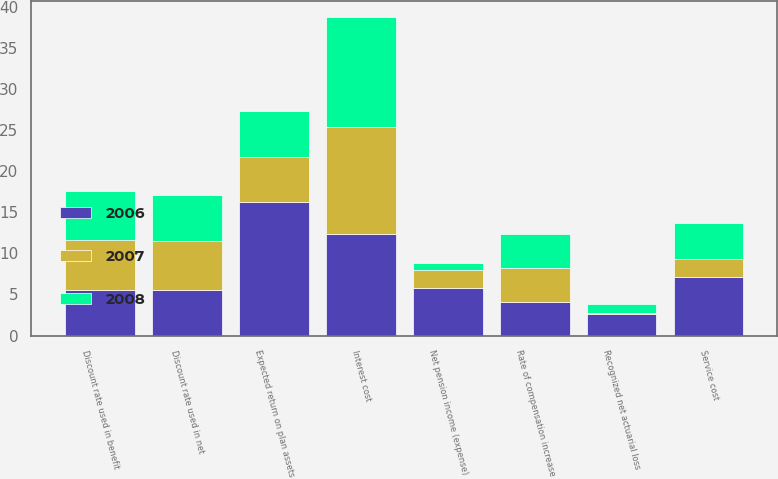<chart> <loc_0><loc_0><loc_500><loc_500><stacked_bar_chart><ecel><fcel>Service cost<fcel>Interest cost<fcel>Expected return on plan assets<fcel>Recognized net actuarial loss<fcel>Net pension income (expense)<fcel>Discount rate used in net<fcel>Discount rate used in benefit<fcel>Rate of compensation increase<nl><fcel>2007<fcel>2.2<fcel>13.1<fcel>5.55<fcel>0.1<fcel>2.2<fcel>6<fcel>6<fcel>4.1<nl><fcel>2008<fcel>4.4<fcel>13.3<fcel>5.55<fcel>1.1<fcel>0.8<fcel>5.6<fcel>6<fcel>4.1<nl><fcel>2006<fcel>7.1<fcel>12.3<fcel>16.2<fcel>2.6<fcel>5.8<fcel>5.5<fcel>5.6<fcel>4.1<nl></chart> 